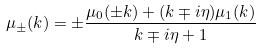Convert formula to latex. <formula><loc_0><loc_0><loc_500><loc_500>\mu _ { \pm } ( k ) = \pm \frac { \mu _ { 0 } ( \pm k ) + ( k \mp i \eta ) \mu _ { 1 } ( k ) } { k \mp i \eta + 1 }</formula> 